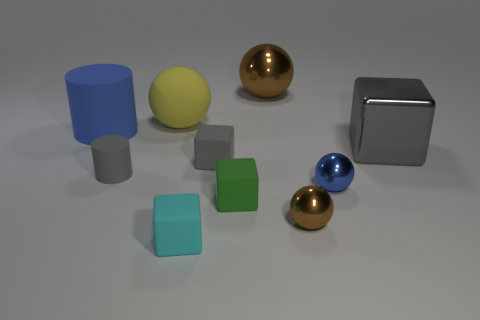How many yellow spheres are in front of the matte cylinder that is in front of the thing left of the tiny gray matte cylinder?
Provide a succinct answer. 0. Do the large shiny object that is on the right side of the tiny blue ball and the sphere on the left side of the tiny green object have the same color?
Your response must be concise. No. What is the color of the cube that is both right of the cyan matte object and to the left of the green thing?
Your response must be concise. Gray. What number of green cubes are the same size as the blue metallic sphere?
Offer a terse response. 1. There is a blue object that is behind the gray cube behind the gray matte cube; what shape is it?
Ensure brevity in your answer.  Cylinder. What is the shape of the brown thing that is behind the blue thing to the right of the brown thing that is behind the big yellow thing?
Ensure brevity in your answer.  Sphere. How many green matte things are the same shape as the gray metallic object?
Offer a terse response. 1. There is a tiny rubber object that is behind the gray cylinder; how many brown things are behind it?
Keep it short and to the point. 1. What number of shiny things are either tiny balls or green blocks?
Your response must be concise. 2. Is there a cyan object that has the same material as the small cylinder?
Offer a very short reply. Yes. 